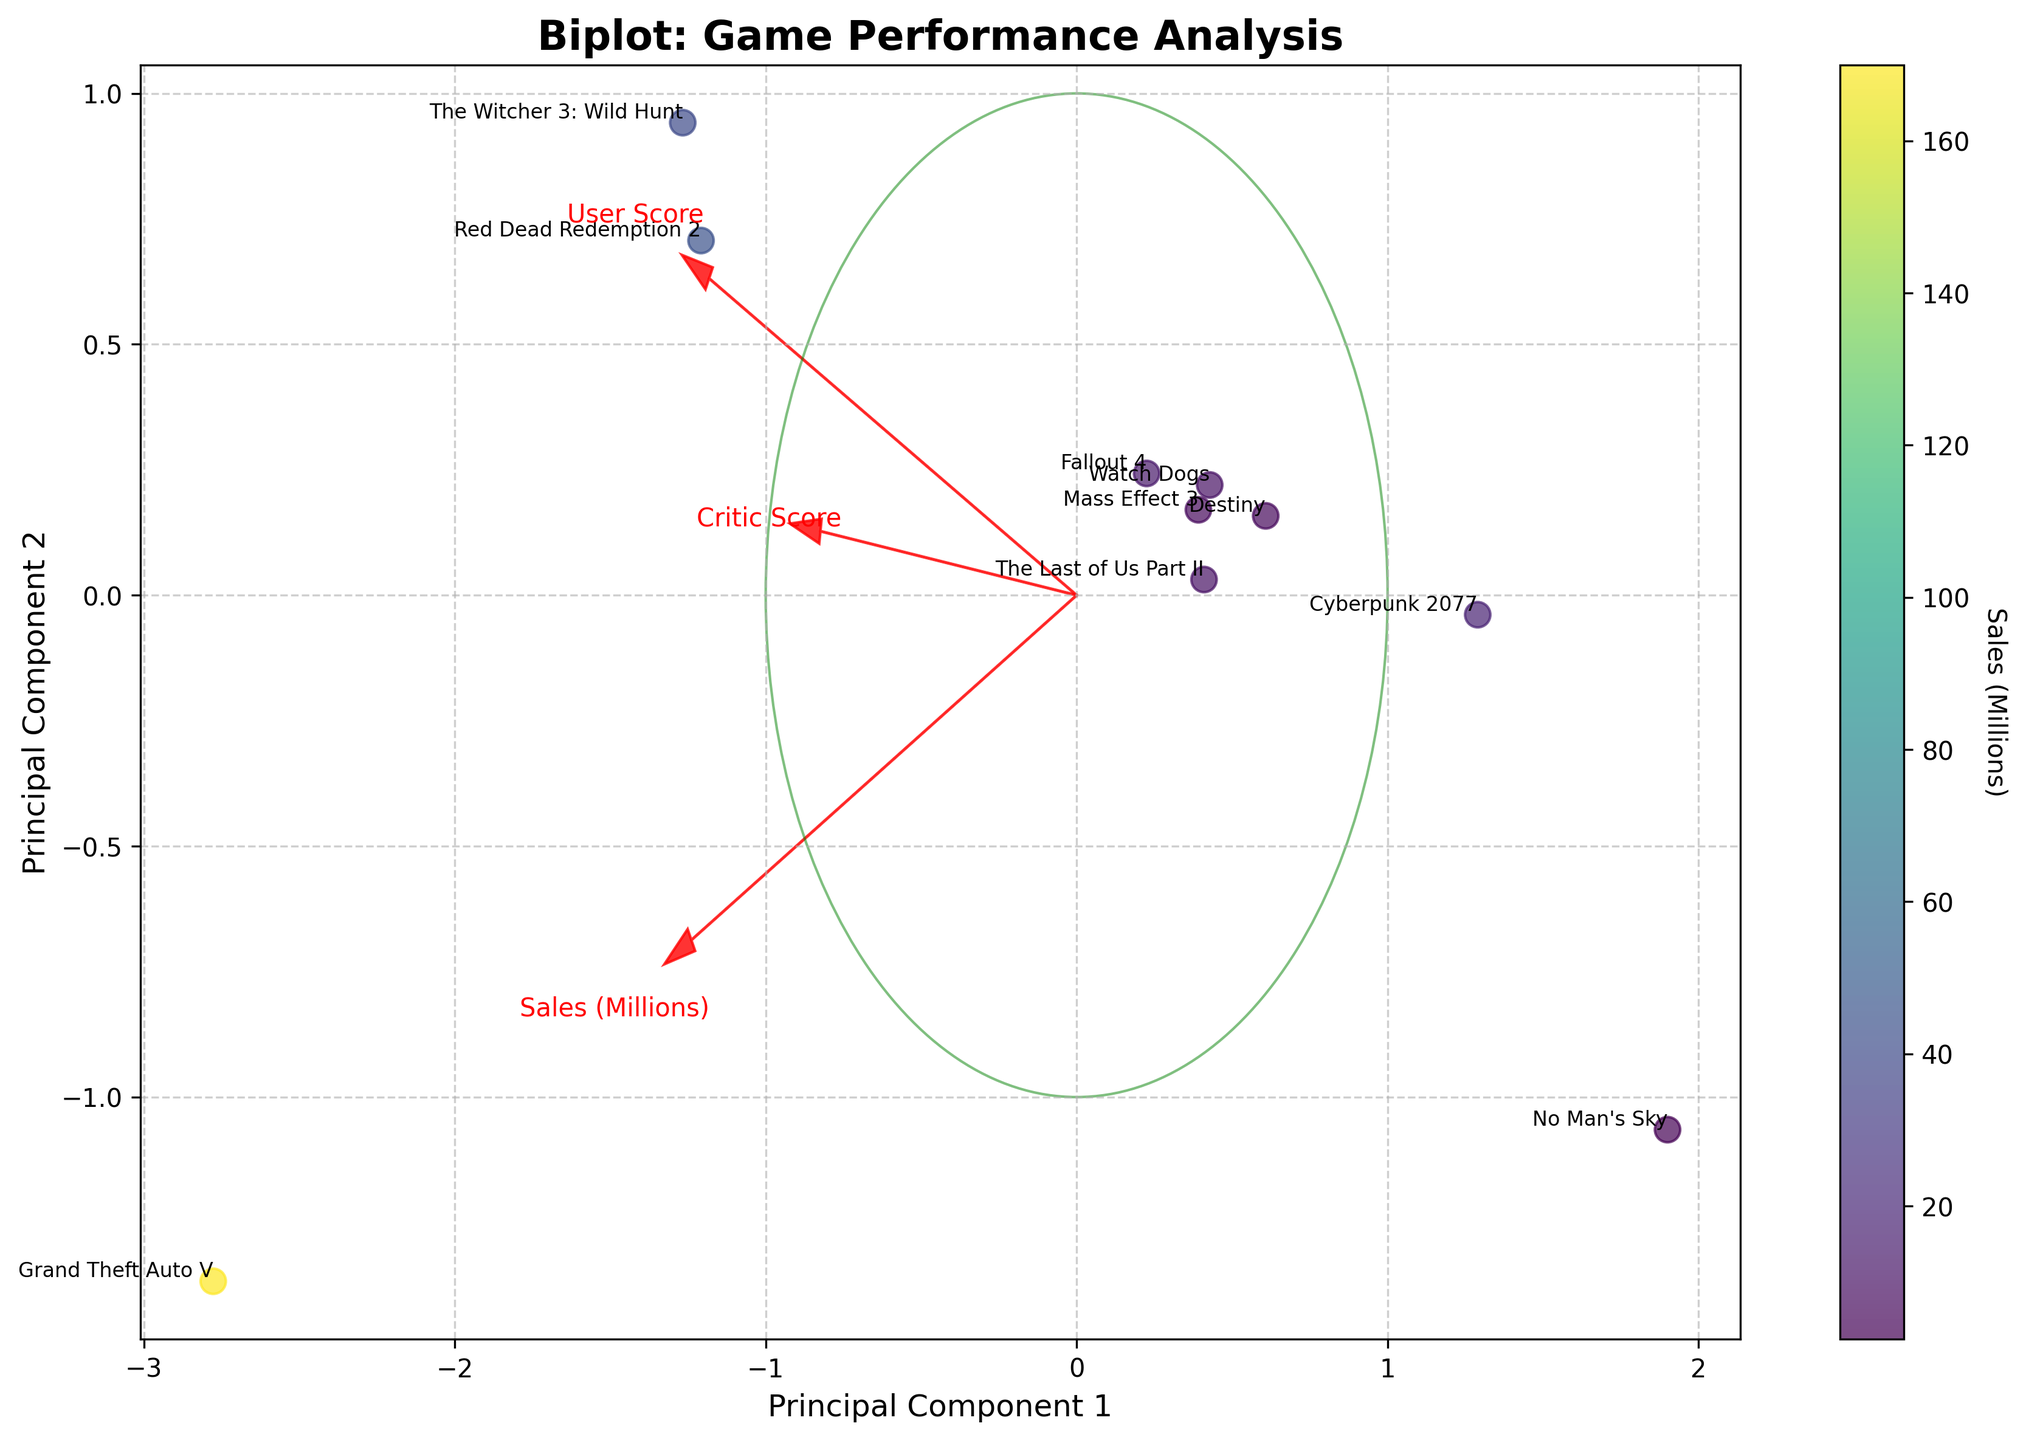What is the title of the figure? The title is located at the top of the figure. It provides a clear, concise description of what the figure represents, making it easy to differentiate from other figures.
Answer: Biplot: Game Performance Analysis What does the color bar represent? The color bar helps interpret the color scale on the scatter plot. By examining the labels on the color bar, we can see that it represents the sales in millions for each game.
Answer: Sales (Millions) Which game achieved the highest user score according to the figure? By locating the user score vector and finding the point farthest along this vector, it is easy to identify "The Witcher 3: Wild Hunt" as it aligns with the highest user score on the plot.
Answer: The Witcher 3: Wild Hunt How are the critic scores and user scores related for "Cyberpunk 2077"? We locate "Cyberpunk 2077" on the biplot and observe its position relative to the critic score and user score vectors. Since the points are close to each other, it suggests a similarity or correlation between the two scores.
Answer: Similar Which game shows the largest discrepancy between critic score and user score? Look for the game that has the most evident distance between its position and the critic score and user score vectors. "The Last of Us Part II" has a high critic score but a significantly lower user score.
Answer: The Last of Us Part II Can you name the game with the highest sales based on this biplot? By examining the color intensity of the points, which correlates with the sales figures as per the color bar, "Grand Theft Auto V" clearly stands out with the highest sales.
Answer: Grand Theft Auto V Which game is positioned closest to the center of the biplot? Analysing the positioning on the plot, the game closest to the origin (0,0) of the plot is "Fallout 4".
Answer: Fallout 4 How does "No Man's Sky" perform in terms of sales compared to other games? Reference the color bar for sales figures and find "No Man's Sky". Its color indicates it has one of the lower sales figures on the chart.
Answer: Lower sales Which axis represents the primary direction of increasing sales? Identify the sales vector on the plot. The direction in which this arrow points indicates the direction of increasing sales.
Answer: X-axis (Principal Component 1) Is there a game where the sales are high but the user score is relatively low? We look at the points with high sales colors but low in the user score vector. "Cyberpunk 2077" has high sales but relatively low user scores compared to its criticisms.
Answer: Cyberpunk 2077 